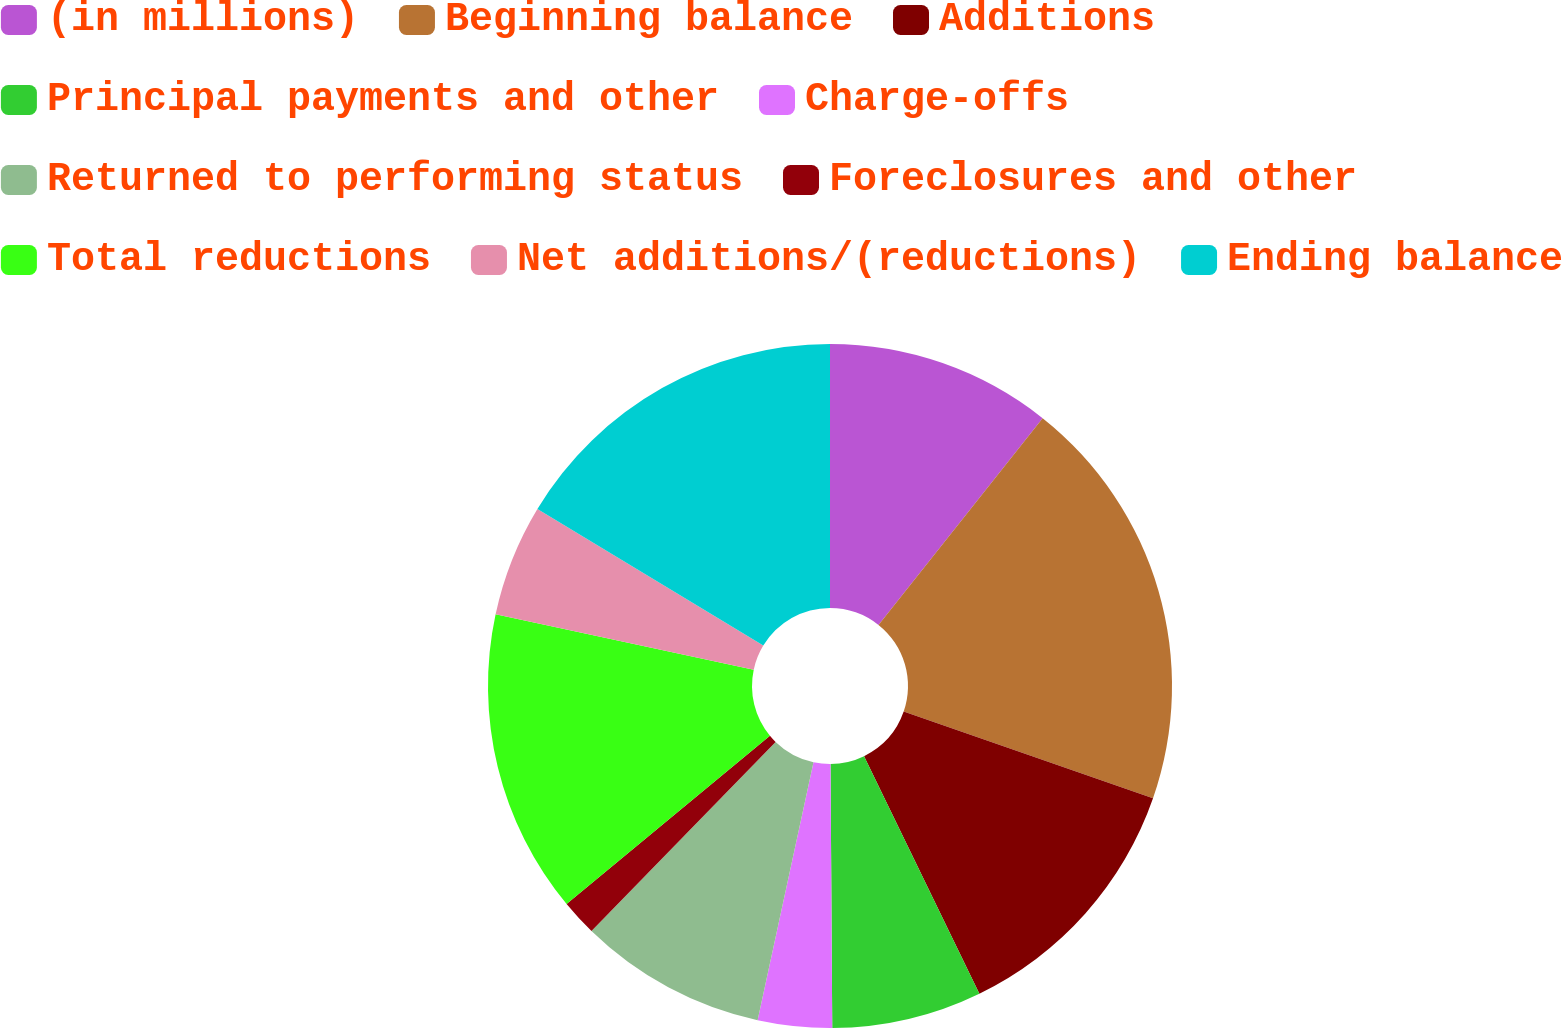Convert chart to OTSL. <chart><loc_0><loc_0><loc_500><loc_500><pie_chart><fcel>(in millions)<fcel>Beginning balance<fcel>Additions<fcel>Principal payments and other<fcel>Charge-offs<fcel>Returned to performing status<fcel>Foreclosures and other<fcel>Total reductions<fcel>Net additions/(reductions)<fcel>Ending balance<nl><fcel>10.68%<fcel>19.65%<fcel>12.48%<fcel>7.09%<fcel>3.5%<fcel>8.89%<fcel>1.71%<fcel>14.37%<fcel>5.3%<fcel>16.34%<nl></chart> 